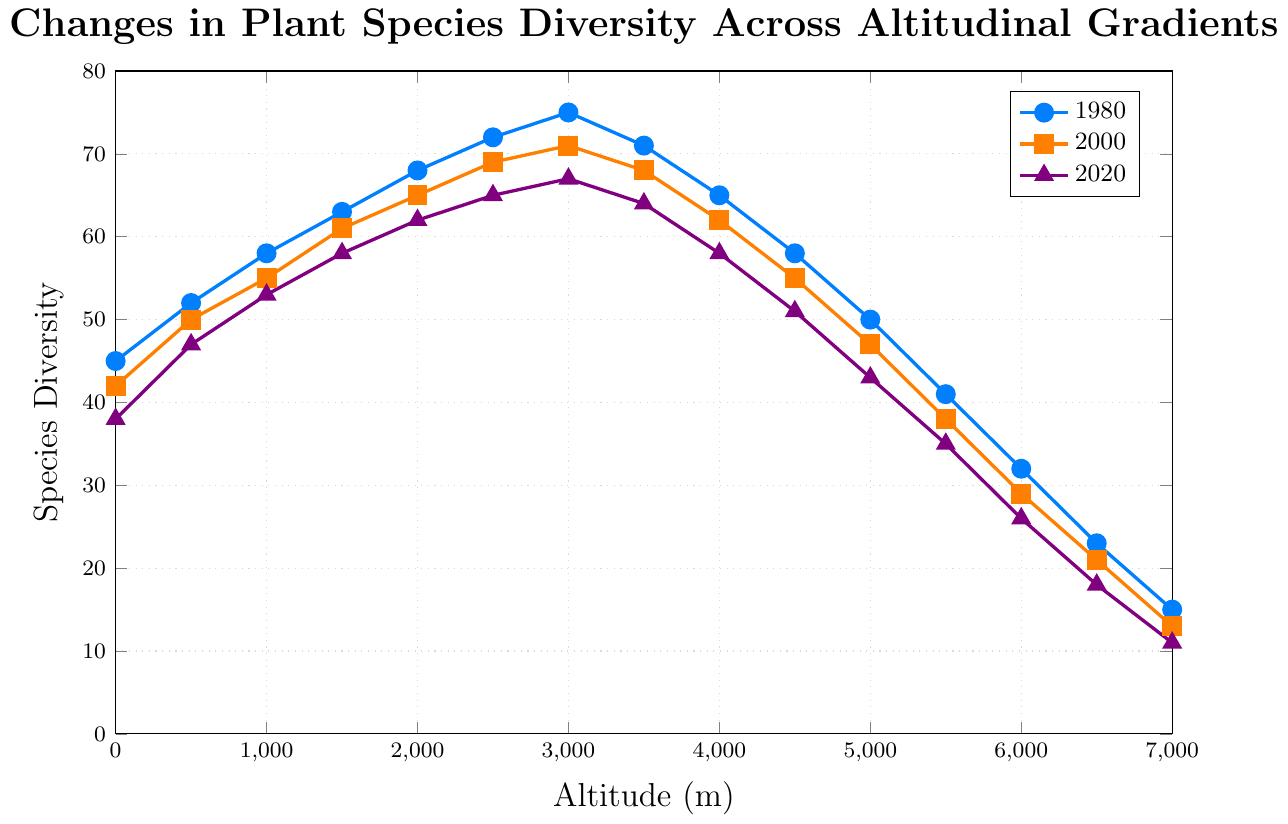What general trend can be observed in plant species diversity from 1980 to 2020? The general trend shows a decline in plant species diversity over the years from 1980 to 2020. All three lines (representing years 1980, 2000, and 2020) show a decreasing trend in diversity values for the same altitudes over time.
Answer: Decline At what altitude does the plant species diversity peak for the year 1980? Observe the highest point on the blue line (1980 data) on the y-axis. The altitude corresponding to this peak is 3000 meters, where the diversity is 75 species.
Answer: 3000 meters How does the species diversity at 2500 meters change from 1980 to 2020? Compare the species diversity values at 2500 meters: 72 (1980), 69 (2000), and 65 (2020). Subtract the 2020 value from the 1980 value to find the difference.
Answer: Decreases by 7 Which year shows the steepest decline in plant species diversity between altitudes 3000 meters and 4500 meters? Calculate the differences in diversity values between 3000 meters and 4500 meters for each year: 1980 (75 - 58 = 17), 2000 (71 - 55 = 16), and 2020 (67 - 51 = 16). Compare these differences.
Answer: 1980 What is the difference in species diversity between the highest and lowest altitude for the year 2000? Find the values at the highest (7000 meters, 13 species) and lowest (0 meters, 42 species) altitudes for 2000. Subtract the value at 7000 meters from the value at 0 meters.
Answer: 29 species At which altitude and year is the plant species diversity the lowest on the graph? Look for the minimum value on the y-axis across all three lines and identify the corresponding altitude and year. The lowest value is 11 species at 7000 meters in 2020 (purple line).
Answer: 7000 meters, 2020 How does the rate of change in species diversity between 4500 and 5000 meters compare for the years 1980 and 2020? Calculate the rate of change for each year by finding the difference in diversity values divided by the difference in altitude: 1980 rate is (58-50)/(4500-5000) = -0.16 species/m, and 2020 rate is (51-43)/(4500-5000) = -0.16 species/m. The rates are equal.
Answer: Equal What is the average species diversity at 2000 meters over the years 1980, 2000, and 2020? Add the diversity values for 2000 meters from each year: 68 (1980), 65 (2000), and 62 (2020). Divide the sum by the number of values (3). The calculation is (68 + 65 + 62) / 3 = 65.
Answer: 65 Between which two altitudes does the 1980 line cross below the 2000 line? Identify the points where the blue line (1980) intersects below the orange line (2000). Observe that the behavior occurs between 6000 and 6500 meters.
Answer: 6000 and 6500 meters 